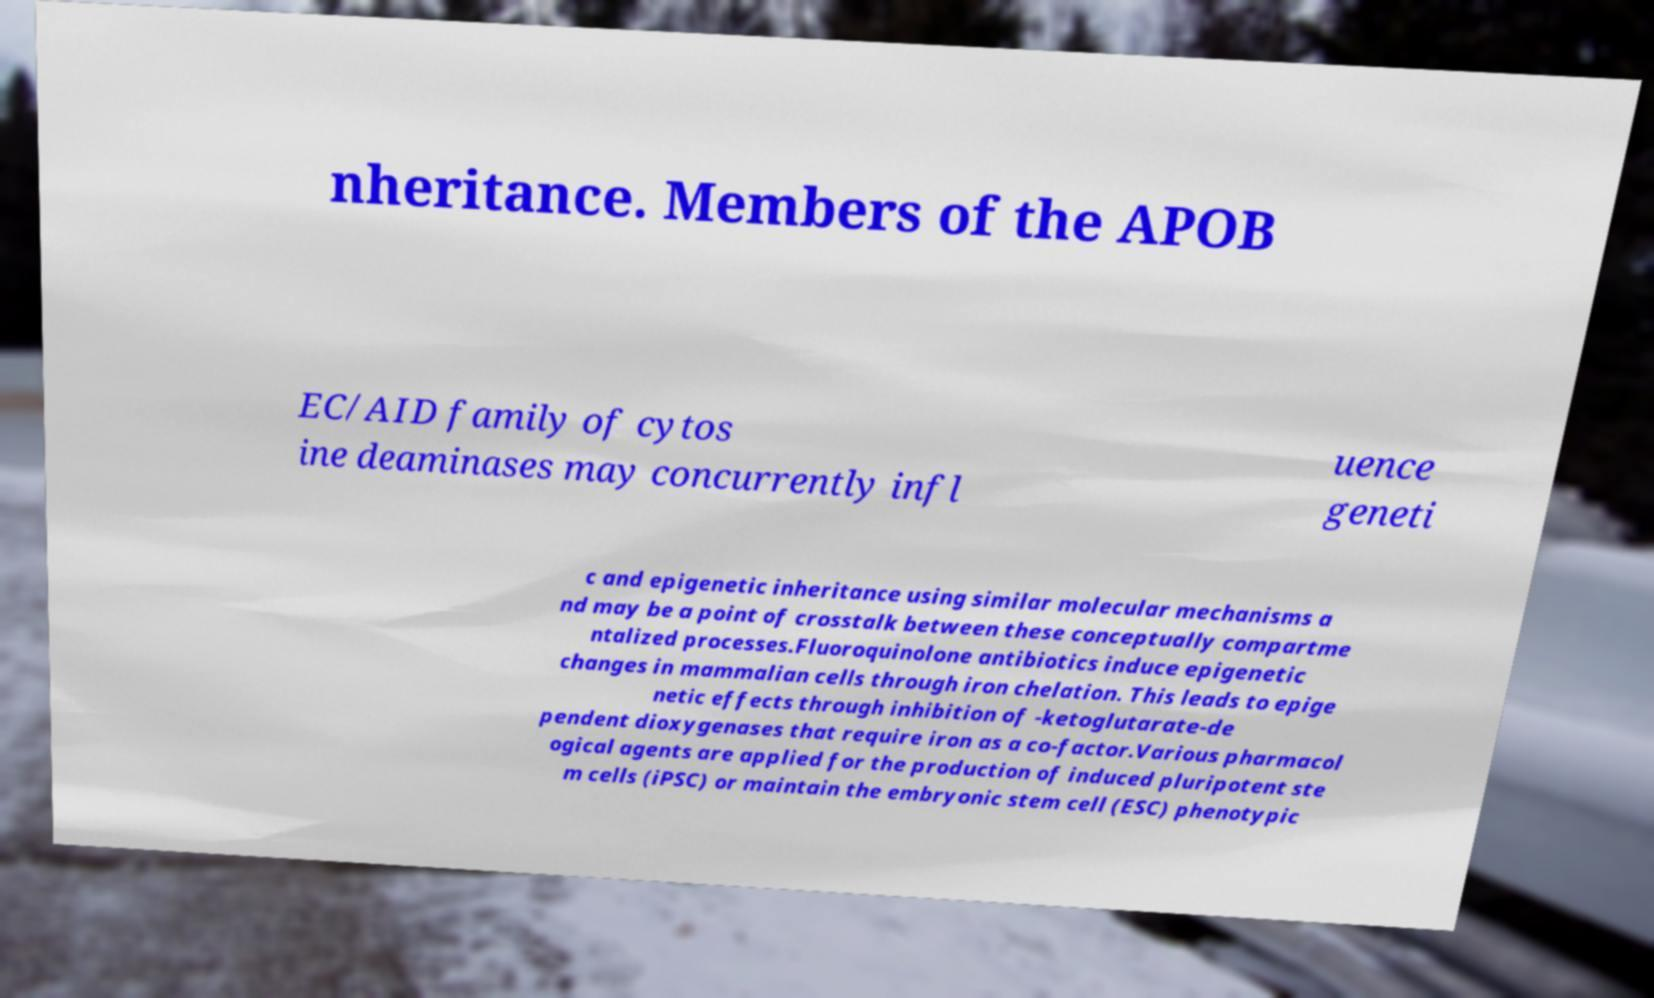Could you assist in decoding the text presented in this image and type it out clearly? nheritance. Members of the APOB EC/AID family of cytos ine deaminases may concurrently infl uence geneti c and epigenetic inheritance using similar molecular mechanisms a nd may be a point of crosstalk between these conceptually compartme ntalized processes.Fluoroquinolone antibiotics induce epigenetic changes in mammalian cells through iron chelation. This leads to epige netic effects through inhibition of -ketoglutarate-de pendent dioxygenases that require iron as a co-factor.Various pharmacol ogical agents are applied for the production of induced pluripotent ste m cells (iPSC) or maintain the embryonic stem cell (ESC) phenotypic 